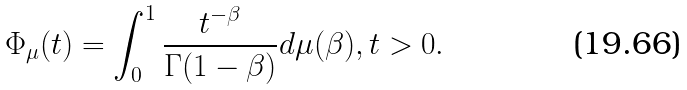Convert formula to latex. <formula><loc_0><loc_0><loc_500><loc_500>\Phi _ { \mu } ( t ) = \int _ { 0 } ^ { 1 } \frac { t ^ { - \beta } } { \Gamma ( 1 - \beta ) } d \mu ( \beta ) , t > 0 .</formula> 